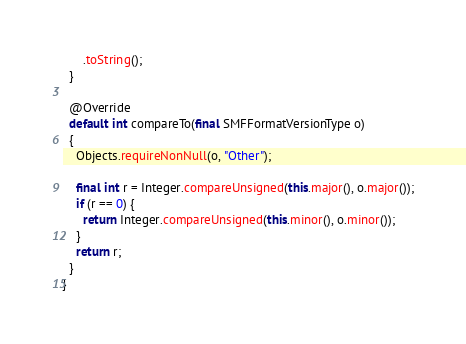<code> <loc_0><loc_0><loc_500><loc_500><_Java_>      .toString();
  }

  @Override
  default int compareTo(final SMFFormatVersionType o)
  {
    Objects.requireNonNull(o, "Other");

    final int r = Integer.compareUnsigned(this.major(), o.major());
    if (r == 0) {
      return Integer.compareUnsigned(this.minor(), o.minor());
    }
    return r;
  }
}
</code> 